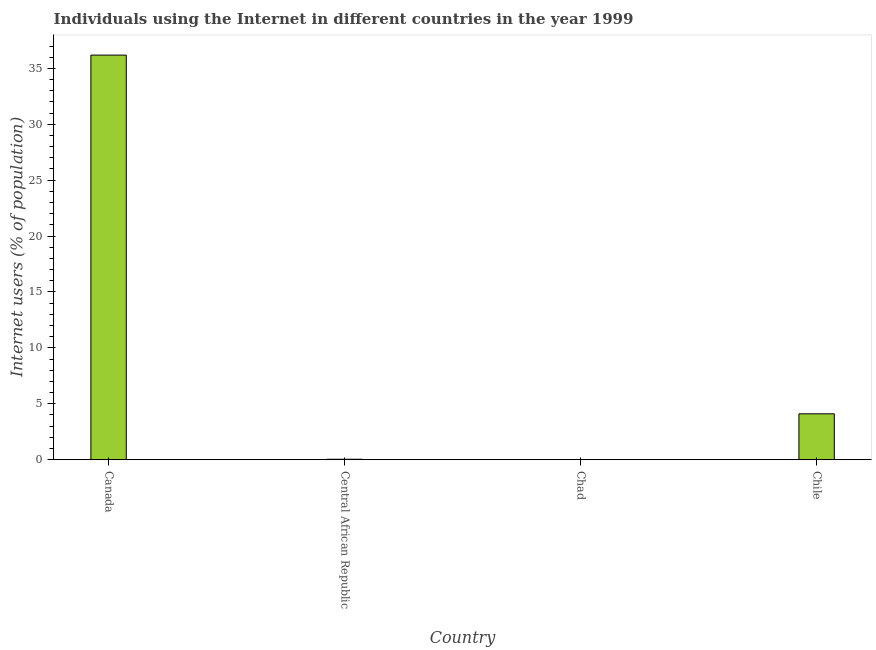Does the graph contain any zero values?
Make the answer very short. No. What is the title of the graph?
Your response must be concise. Individuals using the Internet in different countries in the year 1999. What is the label or title of the X-axis?
Ensure brevity in your answer.  Country. What is the label or title of the Y-axis?
Give a very brief answer. Internet users (% of population). What is the number of internet users in Chad?
Ensure brevity in your answer.  0.01. Across all countries, what is the maximum number of internet users?
Ensure brevity in your answer.  36.19. Across all countries, what is the minimum number of internet users?
Provide a short and direct response. 0.01. In which country was the number of internet users maximum?
Give a very brief answer. Canada. In which country was the number of internet users minimum?
Keep it short and to the point. Chad. What is the sum of the number of internet users?
Offer a very short reply. 40.34. What is the difference between the number of internet users in Central African Republic and Chad?
Offer a terse response. 0.03. What is the average number of internet users per country?
Your answer should be compact. 10.09. What is the median number of internet users?
Make the answer very short. 2.07. What is the ratio of the number of internet users in Canada to that in Central African Republic?
Give a very brief answer. 884.88. Is the number of internet users in Central African Republic less than that in Chad?
Give a very brief answer. No. What is the difference between the highest and the second highest number of internet users?
Keep it short and to the point. 32.08. Is the sum of the number of internet users in Central African Republic and Chile greater than the maximum number of internet users across all countries?
Make the answer very short. No. What is the difference between the highest and the lowest number of internet users?
Your response must be concise. 36.17. In how many countries, is the number of internet users greater than the average number of internet users taken over all countries?
Ensure brevity in your answer.  1. How many bars are there?
Ensure brevity in your answer.  4. How many countries are there in the graph?
Your response must be concise. 4. What is the difference between two consecutive major ticks on the Y-axis?
Your answer should be very brief. 5. Are the values on the major ticks of Y-axis written in scientific E-notation?
Your answer should be very brief. No. What is the Internet users (% of population) in Canada?
Offer a very short reply. 36.19. What is the Internet users (% of population) of Central African Republic?
Offer a very short reply. 0.04. What is the Internet users (% of population) in Chad?
Make the answer very short. 0.01. What is the Internet users (% of population) in Chile?
Provide a short and direct response. 4.1. What is the difference between the Internet users (% of population) in Canada and Central African Republic?
Provide a succinct answer. 36.15. What is the difference between the Internet users (% of population) in Canada and Chad?
Give a very brief answer. 36.17. What is the difference between the Internet users (% of population) in Canada and Chile?
Offer a very short reply. 32.08. What is the difference between the Internet users (% of population) in Central African Republic and Chad?
Keep it short and to the point. 0.03. What is the difference between the Internet users (% of population) in Central African Republic and Chile?
Your answer should be very brief. -4.06. What is the difference between the Internet users (% of population) in Chad and Chile?
Provide a short and direct response. -4.09. What is the ratio of the Internet users (% of population) in Canada to that in Central African Republic?
Your response must be concise. 884.88. What is the ratio of the Internet users (% of population) in Canada to that in Chad?
Keep it short and to the point. 2936.8. What is the ratio of the Internet users (% of population) in Canada to that in Chile?
Provide a succinct answer. 8.82. What is the ratio of the Internet users (% of population) in Central African Republic to that in Chad?
Offer a very short reply. 3.32. What is the ratio of the Internet users (% of population) in Chad to that in Chile?
Your response must be concise. 0. 